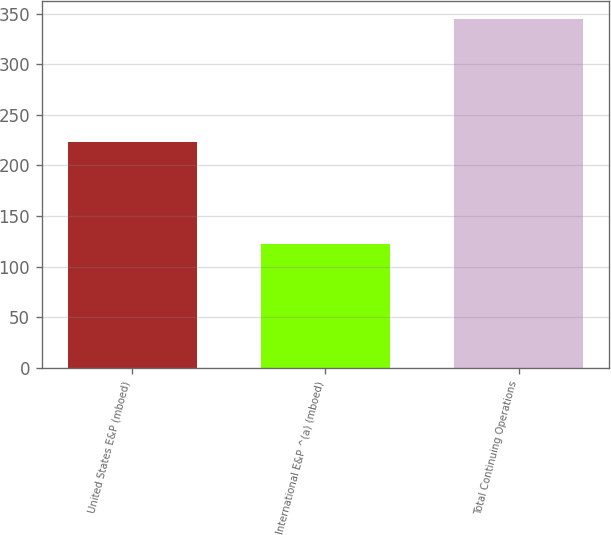Convert chart. <chart><loc_0><loc_0><loc_500><loc_500><bar_chart><fcel>United States E&P (mboed)<fcel>International E&P ^(a) (mboed)<fcel>Total Continuing Operations<nl><fcel>223<fcel>122<fcel>345<nl></chart> 